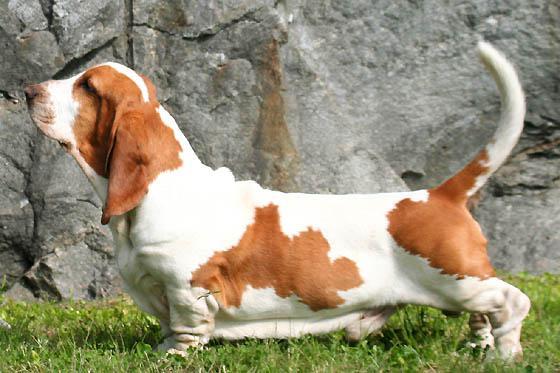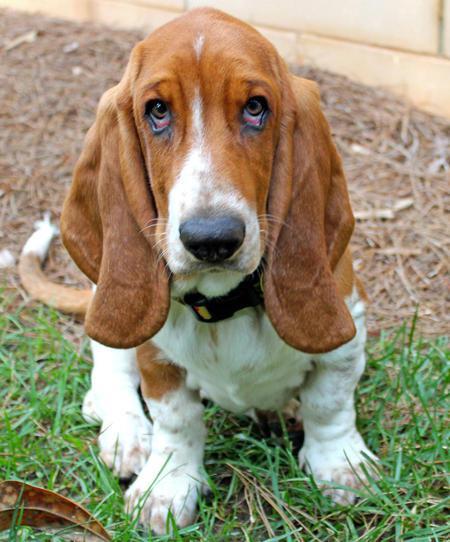The first image is the image on the left, the second image is the image on the right. For the images shown, is this caption "An image shows a brown and white basset on grass in profile facing left." true? Answer yes or no. Yes. 